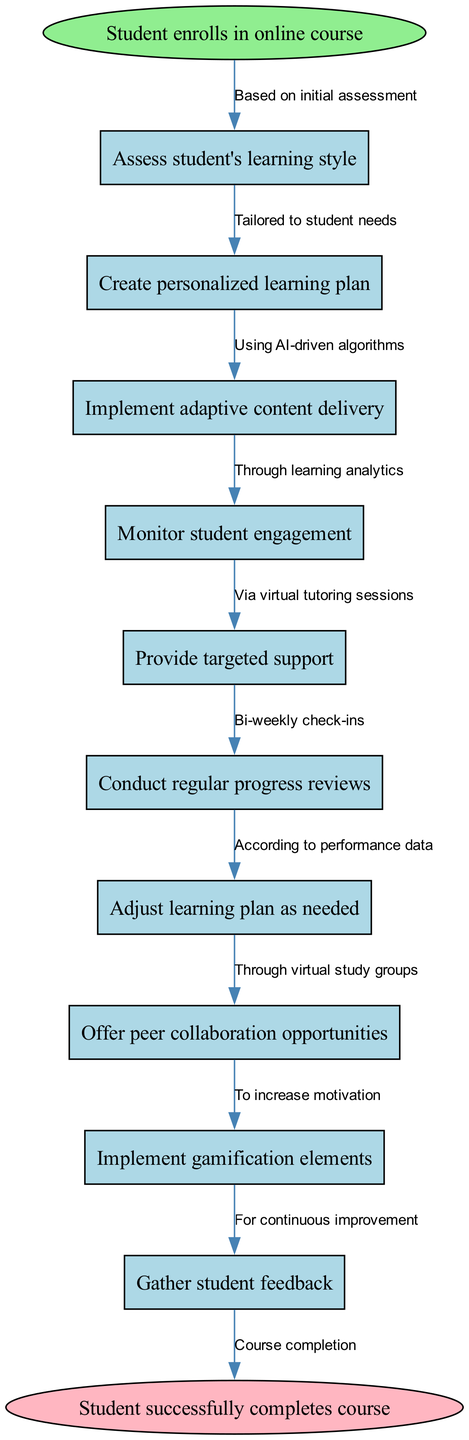What is the starting point of the clinical pathway? The pathway begins with the student enrolling in the online course. This is indicated by the labeled start node in the diagram.
Answer: Student enrolls in online course How many nodes are in the diagram? The diagram contains 10 nodes, as it includes the start node, 8 intermediate nodes, and the end node. Each box or ellipse represents a distinct node in the pathway.
Answer: 10 What does the node "Provide targeted support" lead to? "Provide targeted support" is connected to the next node, which is "Conduct regular progress reviews". This relationship is indicated by the edge connecting these two nodes in the diagram.
Answer: Conduct regular progress reviews What is the final outcome of the pathway? The clinical pathway concludes with the node titled "Student successfully completes course". This is represented by the end node in the diagram.
Answer: Student successfully completes course Which node uses AI-driven algorithms? The node "Implement adaptive content delivery" utilizes AI-driven algorithms as indicated by its connecting edge, which specifies the methodology for delivering content.
Answer: Implement adaptive content delivery What instructional strategy is suggested for increasing motivation? The strategy suggested for increasing motivation in the pathway is "Implement gamification elements", as indicated by the corresponding node.
Answer: Implement gamification elements What type of support is provided based on performance data? The support provided according to performance data is "Adjust learning plan as needed". This is evident from the connection between the nodes.
Answer: Adjust learning plan as needed How frequently are progress reviews conducted? Progress reviews are conducted bi-weekly, as indicated by the edge detail linked to the "Conduct regular progress reviews" node.
Answer: Bi-weekly What opportunity is offered for collaboration among students? The pathway offers "peer collaboration opportunities" to foster collaboration among students. This is specified in the corresponding node.
Answer: Peer collaboration opportunities 